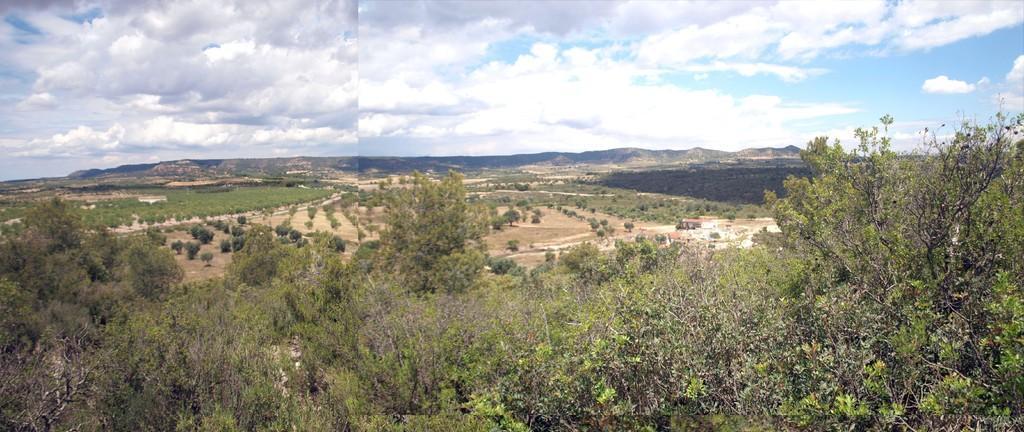Can you describe this image briefly? This is a collage picture. In this picture we can see clouds in the sky, thicket, trees and ground. 